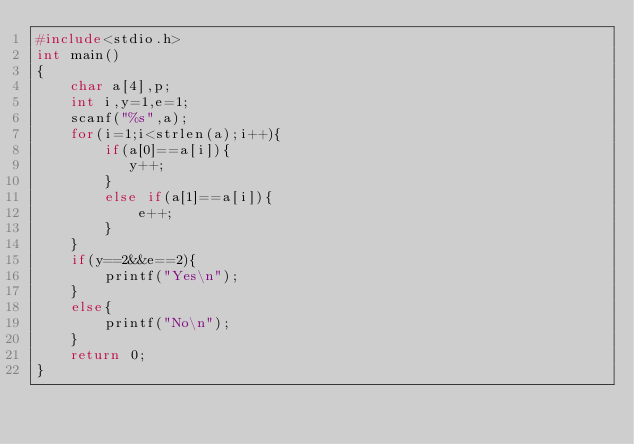<code> <loc_0><loc_0><loc_500><loc_500><_C_>#include<stdio.h>
int main()
{
    char a[4],p;
    int i,y=1,e=1;
    scanf("%s",a);
    for(i=1;i<strlen(a);i++){
        if(a[0]==a[i]){
           y++;
        }
        else if(a[1]==a[i]){
            e++;
        }
    }
    if(y==2&&e==2){
        printf("Yes\n");
    }
    else{
        printf("No\n");
    }
    return 0;
}</code> 